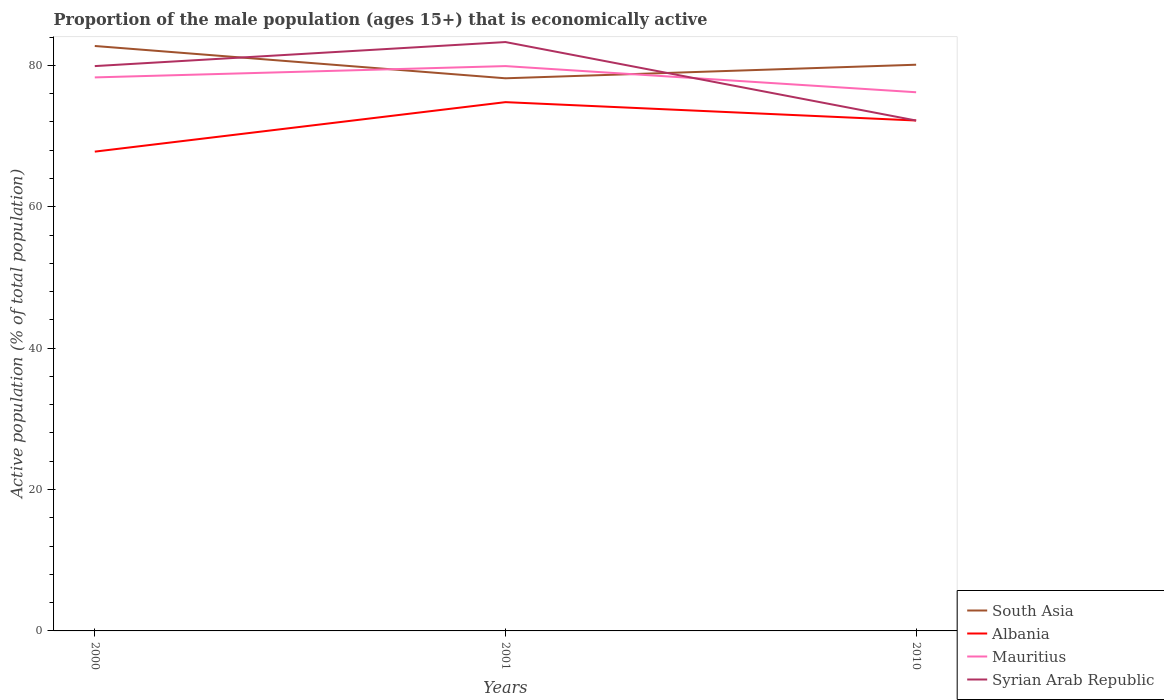How many different coloured lines are there?
Your answer should be compact. 4. Does the line corresponding to South Asia intersect with the line corresponding to Mauritius?
Offer a terse response. Yes. Across all years, what is the maximum proportion of the male population that is economically active in Albania?
Offer a terse response. 67.8. What is the total proportion of the male population that is economically active in Albania in the graph?
Provide a succinct answer. 2.6. What is the difference between the highest and the second highest proportion of the male population that is economically active in Mauritius?
Your response must be concise. 3.7. Is the proportion of the male population that is economically active in Syrian Arab Republic strictly greater than the proportion of the male population that is economically active in Mauritius over the years?
Keep it short and to the point. No. Does the graph contain grids?
Offer a very short reply. No. How many legend labels are there?
Keep it short and to the point. 4. How are the legend labels stacked?
Offer a terse response. Vertical. What is the title of the graph?
Give a very brief answer. Proportion of the male population (ages 15+) that is economically active. Does "Botswana" appear as one of the legend labels in the graph?
Offer a very short reply. No. What is the label or title of the Y-axis?
Give a very brief answer. Active population (% of total population). What is the Active population (% of total population) in South Asia in 2000?
Your answer should be very brief. 82.74. What is the Active population (% of total population) in Albania in 2000?
Your answer should be compact. 67.8. What is the Active population (% of total population) in Mauritius in 2000?
Make the answer very short. 78.3. What is the Active population (% of total population) of Syrian Arab Republic in 2000?
Provide a succinct answer. 79.9. What is the Active population (% of total population) of South Asia in 2001?
Your response must be concise. 78.17. What is the Active population (% of total population) in Albania in 2001?
Offer a very short reply. 74.8. What is the Active population (% of total population) in Mauritius in 2001?
Your answer should be compact. 79.9. What is the Active population (% of total population) in Syrian Arab Republic in 2001?
Offer a very short reply. 83.3. What is the Active population (% of total population) of South Asia in 2010?
Provide a short and direct response. 80.09. What is the Active population (% of total population) of Albania in 2010?
Your response must be concise. 72.2. What is the Active population (% of total population) of Mauritius in 2010?
Keep it short and to the point. 76.2. What is the Active population (% of total population) in Syrian Arab Republic in 2010?
Provide a short and direct response. 72.2. Across all years, what is the maximum Active population (% of total population) of South Asia?
Your answer should be very brief. 82.74. Across all years, what is the maximum Active population (% of total population) of Albania?
Make the answer very short. 74.8. Across all years, what is the maximum Active population (% of total population) in Mauritius?
Offer a terse response. 79.9. Across all years, what is the maximum Active population (% of total population) in Syrian Arab Republic?
Offer a terse response. 83.3. Across all years, what is the minimum Active population (% of total population) of South Asia?
Your response must be concise. 78.17. Across all years, what is the minimum Active population (% of total population) of Albania?
Give a very brief answer. 67.8. Across all years, what is the minimum Active population (% of total population) in Mauritius?
Your answer should be compact. 76.2. Across all years, what is the minimum Active population (% of total population) in Syrian Arab Republic?
Your response must be concise. 72.2. What is the total Active population (% of total population) of South Asia in the graph?
Your answer should be compact. 241.01. What is the total Active population (% of total population) of Albania in the graph?
Provide a succinct answer. 214.8. What is the total Active population (% of total population) in Mauritius in the graph?
Provide a succinct answer. 234.4. What is the total Active population (% of total population) of Syrian Arab Republic in the graph?
Your answer should be compact. 235.4. What is the difference between the Active population (% of total population) in South Asia in 2000 and that in 2001?
Keep it short and to the point. 4.57. What is the difference between the Active population (% of total population) in South Asia in 2000 and that in 2010?
Provide a short and direct response. 2.65. What is the difference between the Active population (% of total population) in Albania in 2000 and that in 2010?
Make the answer very short. -4.4. What is the difference between the Active population (% of total population) in South Asia in 2001 and that in 2010?
Provide a short and direct response. -1.92. What is the difference between the Active population (% of total population) of Albania in 2001 and that in 2010?
Offer a very short reply. 2.6. What is the difference between the Active population (% of total population) of Syrian Arab Republic in 2001 and that in 2010?
Provide a short and direct response. 11.1. What is the difference between the Active population (% of total population) of South Asia in 2000 and the Active population (% of total population) of Albania in 2001?
Provide a succinct answer. 7.94. What is the difference between the Active population (% of total population) in South Asia in 2000 and the Active population (% of total population) in Mauritius in 2001?
Provide a short and direct response. 2.84. What is the difference between the Active population (% of total population) of South Asia in 2000 and the Active population (% of total population) of Syrian Arab Republic in 2001?
Give a very brief answer. -0.56. What is the difference between the Active population (% of total population) in Albania in 2000 and the Active population (% of total population) in Syrian Arab Republic in 2001?
Your answer should be compact. -15.5. What is the difference between the Active population (% of total population) of Mauritius in 2000 and the Active population (% of total population) of Syrian Arab Republic in 2001?
Provide a succinct answer. -5. What is the difference between the Active population (% of total population) of South Asia in 2000 and the Active population (% of total population) of Albania in 2010?
Your answer should be very brief. 10.54. What is the difference between the Active population (% of total population) in South Asia in 2000 and the Active population (% of total population) in Mauritius in 2010?
Give a very brief answer. 6.54. What is the difference between the Active population (% of total population) in South Asia in 2000 and the Active population (% of total population) in Syrian Arab Republic in 2010?
Provide a short and direct response. 10.54. What is the difference between the Active population (% of total population) of Albania in 2000 and the Active population (% of total population) of Mauritius in 2010?
Ensure brevity in your answer.  -8.4. What is the difference between the Active population (% of total population) of Albania in 2000 and the Active population (% of total population) of Syrian Arab Republic in 2010?
Offer a very short reply. -4.4. What is the difference between the Active population (% of total population) of Mauritius in 2000 and the Active population (% of total population) of Syrian Arab Republic in 2010?
Your answer should be very brief. 6.1. What is the difference between the Active population (% of total population) of South Asia in 2001 and the Active population (% of total population) of Albania in 2010?
Your answer should be compact. 5.97. What is the difference between the Active population (% of total population) in South Asia in 2001 and the Active population (% of total population) in Mauritius in 2010?
Provide a short and direct response. 1.97. What is the difference between the Active population (% of total population) of South Asia in 2001 and the Active population (% of total population) of Syrian Arab Republic in 2010?
Give a very brief answer. 5.97. What is the average Active population (% of total population) of South Asia per year?
Offer a very short reply. 80.34. What is the average Active population (% of total population) of Albania per year?
Provide a succinct answer. 71.6. What is the average Active population (% of total population) in Mauritius per year?
Give a very brief answer. 78.13. What is the average Active population (% of total population) in Syrian Arab Republic per year?
Offer a terse response. 78.47. In the year 2000, what is the difference between the Active population (% of total population) of South Asia and Active population (% of total population) of Albania?
Provide a succinct answer. 14.94. In the year 2000, what is the difference between the Active population (% of total population) of South Asia and Active population (% of total population) of Mauritius?
Ensure brevity in your answer.  4.44. In the year 2000, what is the difference between the Active population (% of total population) of South Asia and Active population (% of total population) of Syrian Arab Republic?
Ensure brevity in your answer.  2.84. In the year 2001, what is the difference between the Active population (% of total population) of South Asia and Active population (% of total population) of Albania?
Provide a short and direct response. 3.37. In the year 2001, what is the difference between the Active population (% of total population) in South Asia and Active population (% of total population) in Mauritius?
Your answer should be very brief. -1.73. In the year 2001, what is the difference between the Active population (% of total population) in South Asia and Active population (% of total population) in Syrian Arab Republic?
Offer a very short reply. -5.13. In the year 2001, what is the difference between the Active population (% of total population) in Albania and Active population (% of total population) in Syrian Arab Republic?
Give a very brief answer. -8.5. In the year 2010, what is the difference between the Active population (% of total population) of South Asia and Active population (% of total population) of Albania?
Provide a succinct answer. 7.89. In the year 2010, what is the difference between the Active population (% of total population) in South Asia and Active population (% of total population) in Mauritius?
Ensure brevity in your answer.  3.89. In the year 2010, what is the difference between the Active population (% of total population) of South Asia and Active population (% of total population) of Syrian Arab Republic?
Offer a very short reply. 7.89. In the year 2010, what is the difference between the Active population (% of total population) in Albania and Active population (% of total population) in Syrian Arab Republic?
Provide a short and direct response. 0. What is the ratio of the Active population (% of total population) of South Asia in 2000 to that in 2001?
Make the answer very short. 1.06. What is the ratio of the Active population (% of total population) in Albania in 2000 to that in 2001?
Offer a terse response. 0.91. What is the ratio of the Active population (% of total population) of Syrian Arab Republic in 2000 to that in 2001?
Provide a short and direct response. 0.96. What is the ratio of the Active population (% of total population) of South Asia in 2000 to that in 2010?
Offer a very short reply. 1.03. What is the ratio of the Active population (% of total population) of Albania in 2000 to that in 2010?
Offer a very short reply. 0.94. What is the ratio of the Active population (% of total population) of Mauritius in 2000 to that in 2010?
Offer a very short reply. 1.03. What is the ratio of the Active population (% of total population) in Syrian Arab Republic in 2000 to that in 2010?
Provide a succinct answer. 1.11. What is the ratio of the Active population (% of total population) in South Asia in 2001 to that in 2010?
Provide a succinct answer. 0.98. What is the ratio of the Active population (% of total population) in Albania in 2001 to that in 2010?
Offer a terse response. 1.04. What is the ratio of the Active population (% of total population) of Mauritius in 2001 to that in 2010?
Offer a terse response. 1.05. What is the ratio of the Active population (% of total population) of Syrian Arab Republic in 2001 to that in 2010?
Your response must be concise. 1.15. What is the difference between the highest and the second highest Active population (% of total population) of South Asia?
Provide a short and direct response. 2.65. What is the difference between the highest and the second highest Active population (% of total population) in Albania?
Offer a terse response. 2.6. What is the difference between the highest and the lowest Active population (% of total population) of South Asia?
Your answer should be very brief. 4.57. What is the difference between the highest and the lowest Active population (% of total population) in Syrian Arab Republic?
Provide a short and direct response. 11.1. 